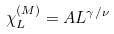Convert formula to latex. <formula><loc_0><loc_0><loc_500><loc_500>\chi ^ { ( M ) } _ { L } = A L ^ { \gamma / \nu }</formula> 